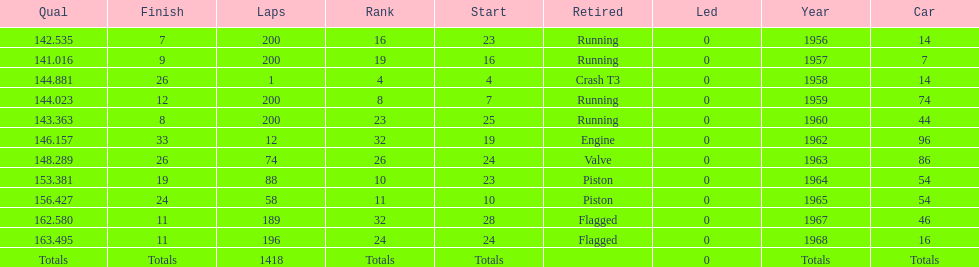What year did he have the same number car as 1964? 1965. 